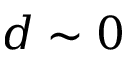Convert formula to latex. <formula><loc_0><loc_0><loc_500><loc_500>d \sim 0</formula> 